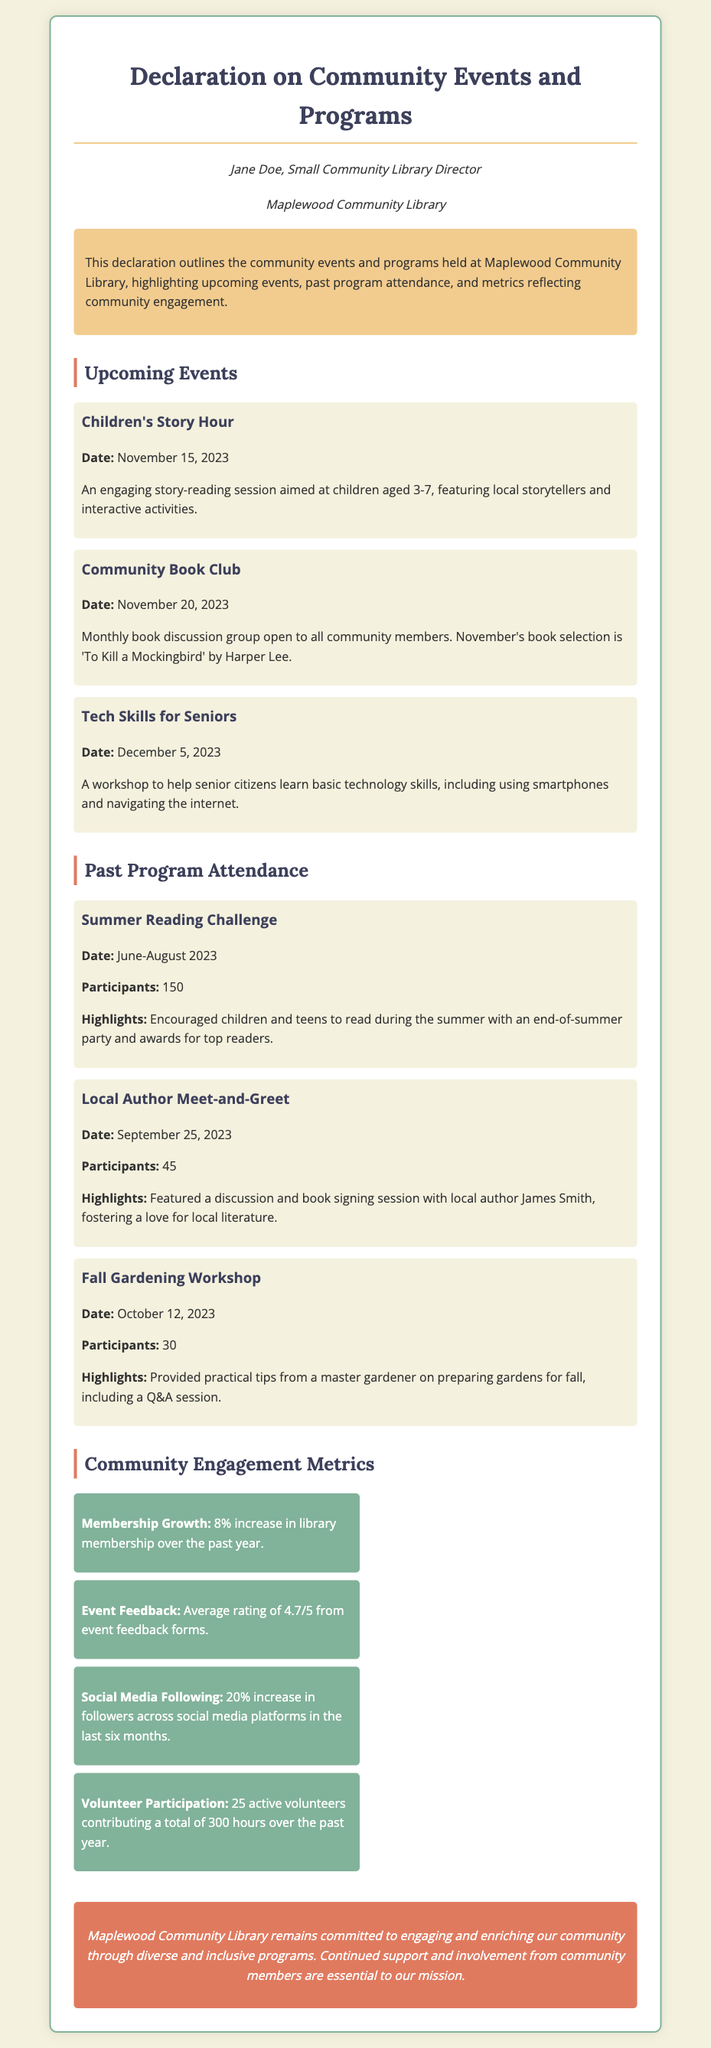What is the date of the Children's Story Hour? The document states that the Children's Story Hour is scheduled for November 15, 2023.
Answer: November 15, 2023 How many participants were in the Summer Reading Challenge? The document indicates that there were 150 participants in the Summer Reading Challenge.
Answer: 150 What is the average rating from event feedback forms? According to the document, the average rating from event feedback forms is 4.7 out of 5.
Answer: 4.7/5 What event is happening on December 5, 2023? The document lists a workshop called "Tech Skills for Seniors" happening on December 5, 2023.
Answer: Tech Skills for Seniors How many active volunteers contributed to the library in the past year? The document mentions a total of 25 active volunteers who contributed hours over the past year.
Answer: 25 What book is being discussed in the Community Book Club? The document specifies that the book for November's Community Book Club is 'To Kill a Mockingbird' by Harper Lee.
Answer: 'To Kill a Mockingbird' What is the highlighted benefit of the Local Author Meet-and-Greet? The document highlights that the event fostered a love for local literature through discussion and book signing.
Answer: Fostered a love for local literature What percentage increase has there been in library membership? The document states that there has been an 8% increase in library membership over the past year.
Answer: 8% What is the main goal of the Maplewood Community Library as stated in the conclusion? The document concludes with a statement about the library's commitment to engaging and enriching the community.
Answer: Engaging and enriching the community 